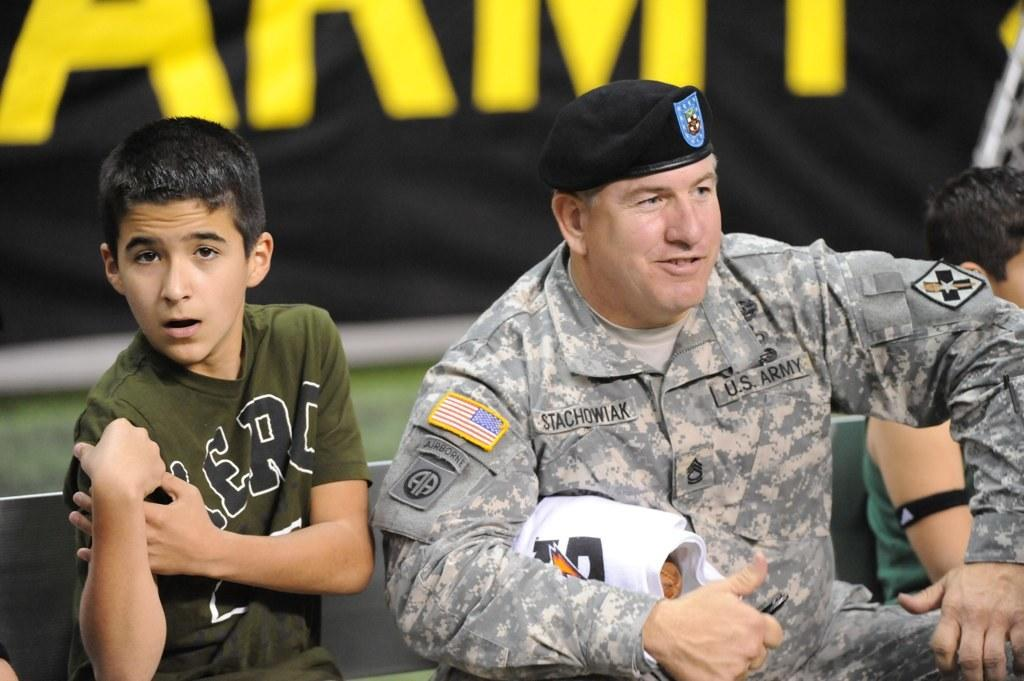Who is present in the image? There is a boy and a man in the image. What are the boy and man doing in the image? Both the boy and man are sitting on a bench. What can be seen in the background of the image? There is an advertisement in the background of the image. What type of wire is the boy holding in the image? There is no wire present in the image; the boy is simply sitting on the bench with the man. 